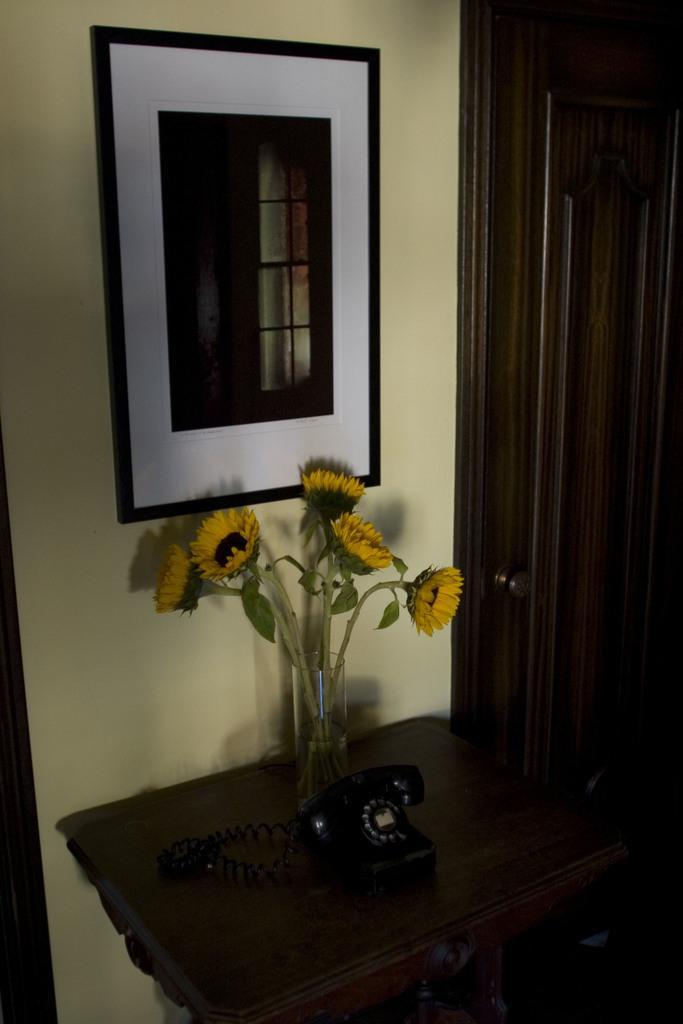Could you give a brief overview of what you see in this image? In the center we can see table,on table there is a land phone,flower vase. In the background we can see wall,door and photo frame. 